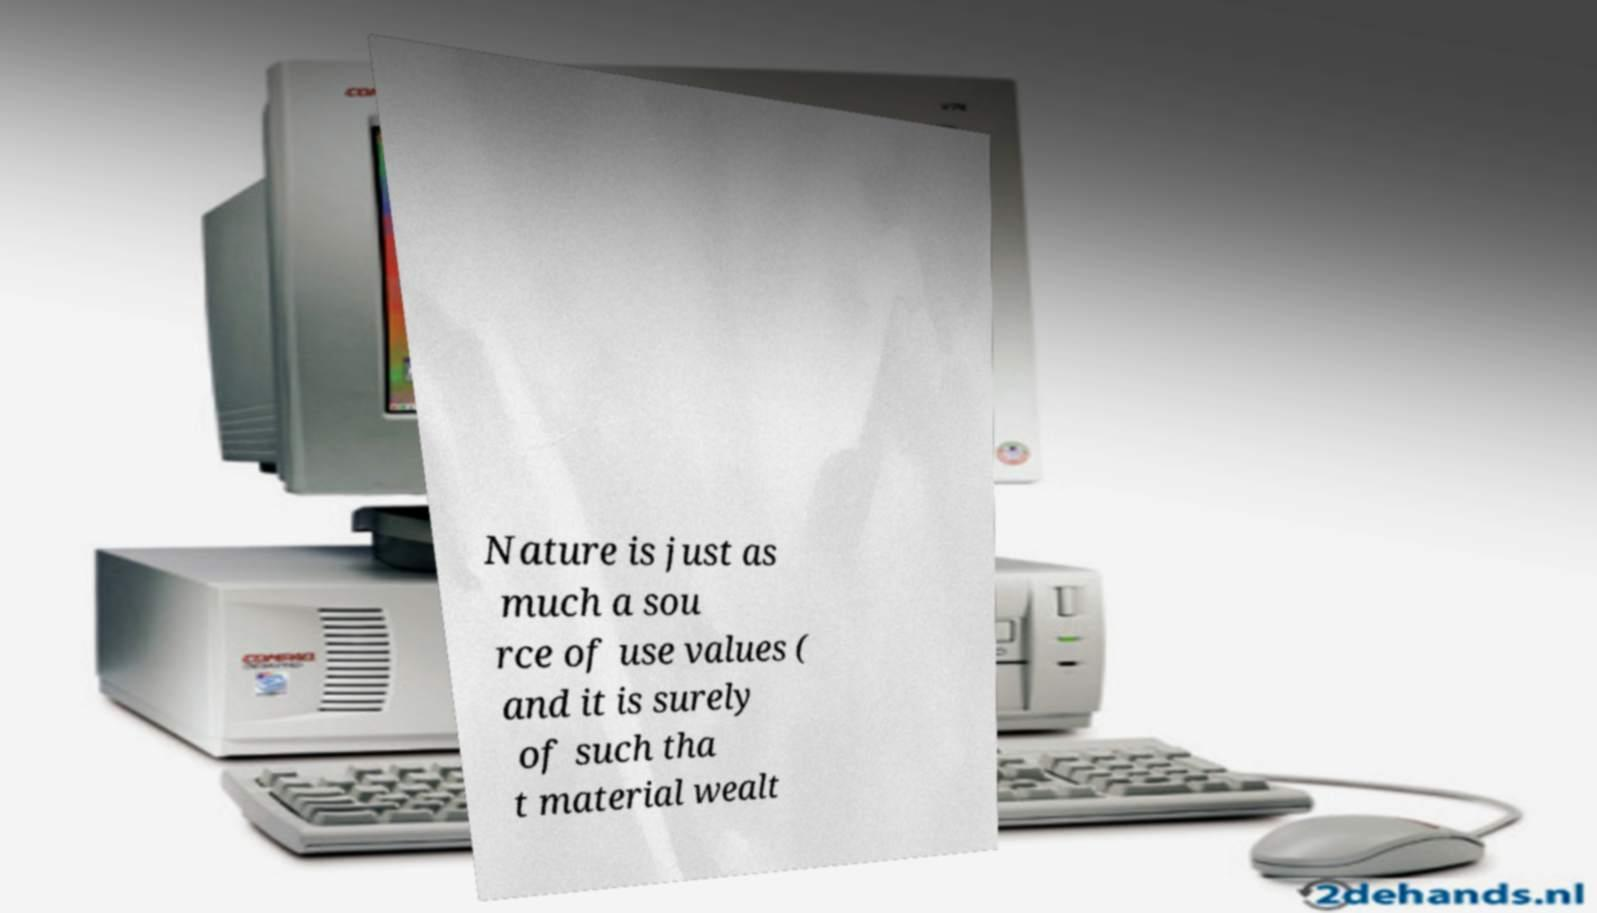Can you read and provide the text displayed in the image?This photo seems to have some interesting text. Can you extract and type it out for me? Nature is just as much a sou rce of use values ( and it is surely of such tha t material wealt 